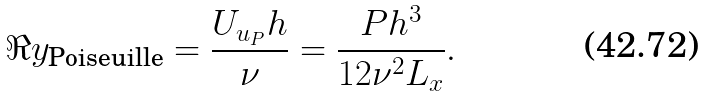<formula> <loc_0><loc_0><loc_500><loc_500>\Re y _ { \text {Poiseuille} } = \frac { U _ { u _ { P } } h } { \nu } = \frac { P h ^ { 3 } } { 1 2 \nu ^ { 2 } L _ { x } } .</formula> 